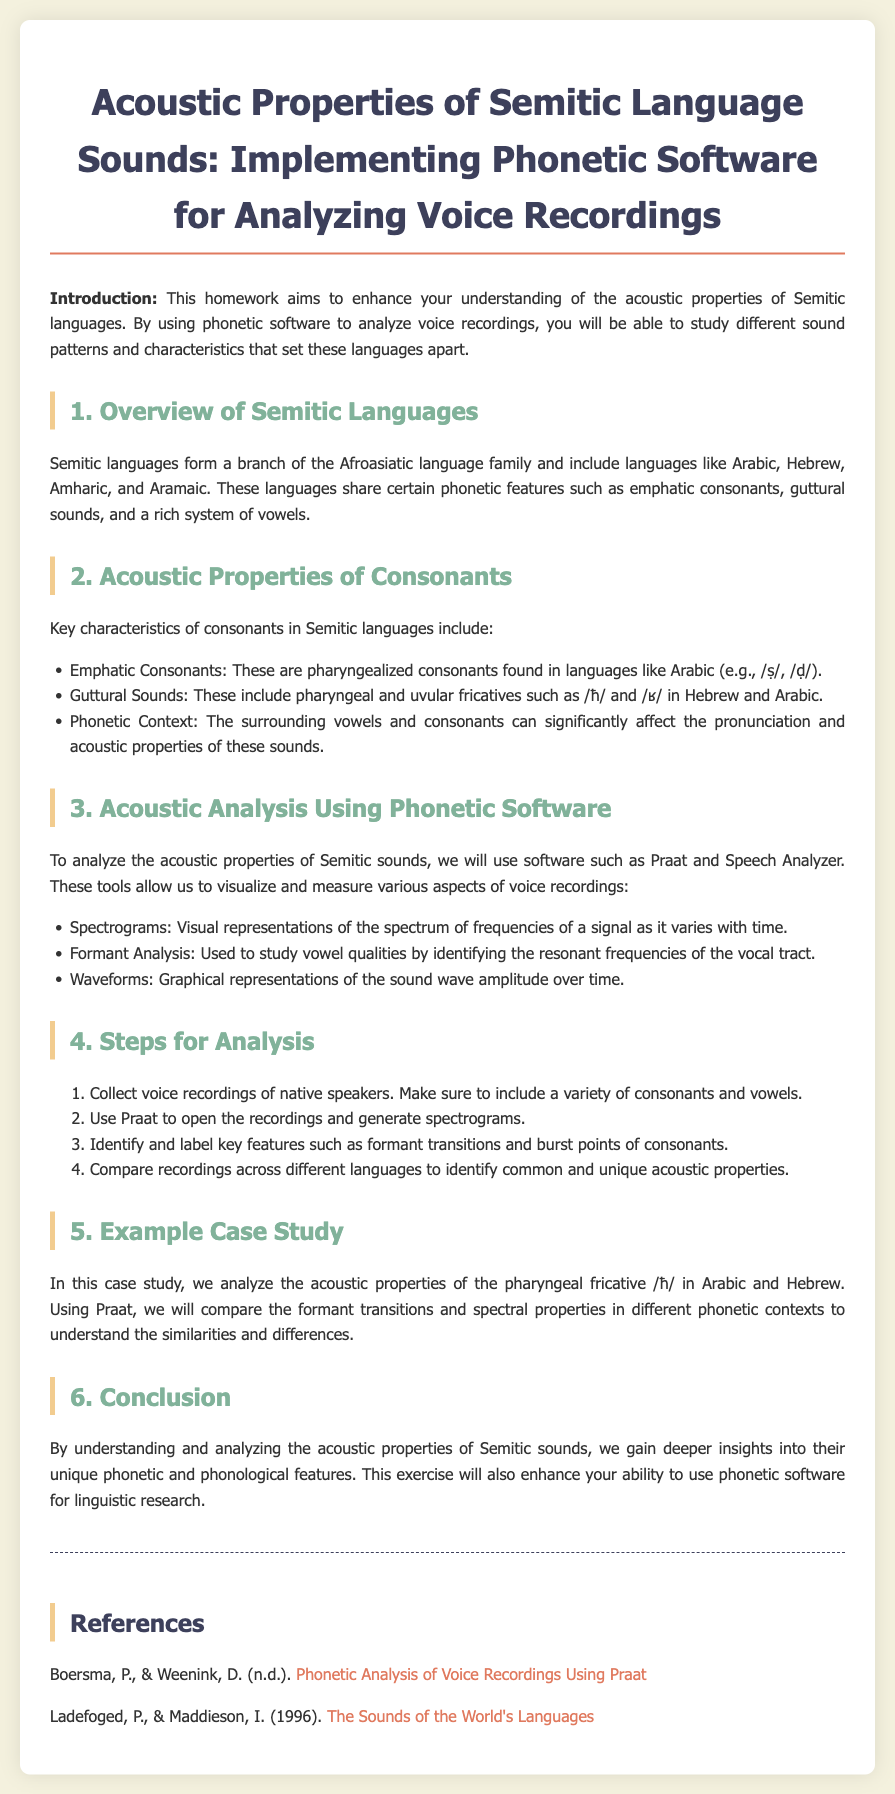what is the title of the homework? The title is clearly stated at the top of the document as "Acoustic Properties of Semitic Language Sounds: Implementing Phonetic Software for Analyzing Voice Recordings."
Answer: Acoustic Properties of Semitic Language Sounds: Implementing Phonetic Software for Analyzing Voice Recordings which languages are classified as Semitic languages? The document lists Arabic, Hebrew, Amharic, and Aramaic as examples of Semitic languages.
Answer: Arabic, Hebrew, Amharic, and Aramaic what kind of sounds are included under guttural sounds? Guttural sounds mentioned include pharyngeal and uvular fricatives such as /ħ/ and /ʁ/.
Answer: pharyngeal and uvular fricatives what is the first step in analyzing voice recordings? The first step in the analysis process is to collect voice recordings of native speakers, ensuring a variety of consonants and vowels are included.
Answer: Collect voice recordings of native speakers which software is mentioned for acoustic analysis? The document mentions using Praat and Speech Analyzer for analyzing the acoustic properties of Semitic sounds.
Answer: Praat and Speech Analyzer what is the purpose of using spectrograms? Spectrograms serve as visual representations of the spectrum of frequencies of a signal as it varies with time.
Answer: Visual representations of the spectrum of frequencies what property is being examined in the example case study? In the case study, the acoustic properties of the pharyngeal fricative /ħ/ are being examined.
Answer: Pharyngeal fricative /ħ/ how does understanding acoustic properties benefit linguistic research? Understanding these properties provides deeper insights into unique phonetic and phonological features of Semitic languages, which enhances linguistic research abilities.
Answer: Deeper insights into unique phonetic and phonological features 